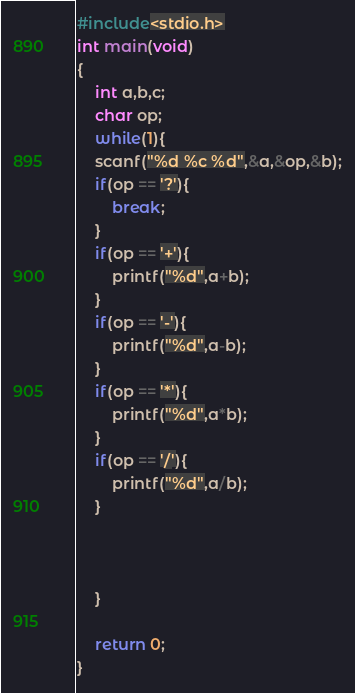Convert code to text. <code><loc_0><loc_0><loc_500><loc_500><_C_>#include<stdio.h>
int main(void)
{
    int a,b,c;
    char op;
    while(1){
    scanf("%d %c %d",&a,&op,&b);
    if(op == '?'){
        break;
    }
    if(op == '+'){
        printf("%d",a+b);
    }
    if(op == '-'){
        printf("%d",a-b);
    }
    if(op == '*'){
        printf("%d",a*b);
    }
    if(op == '/'){
        printf("%d",a/b);
    }



    }

    return 0;
}</code> 